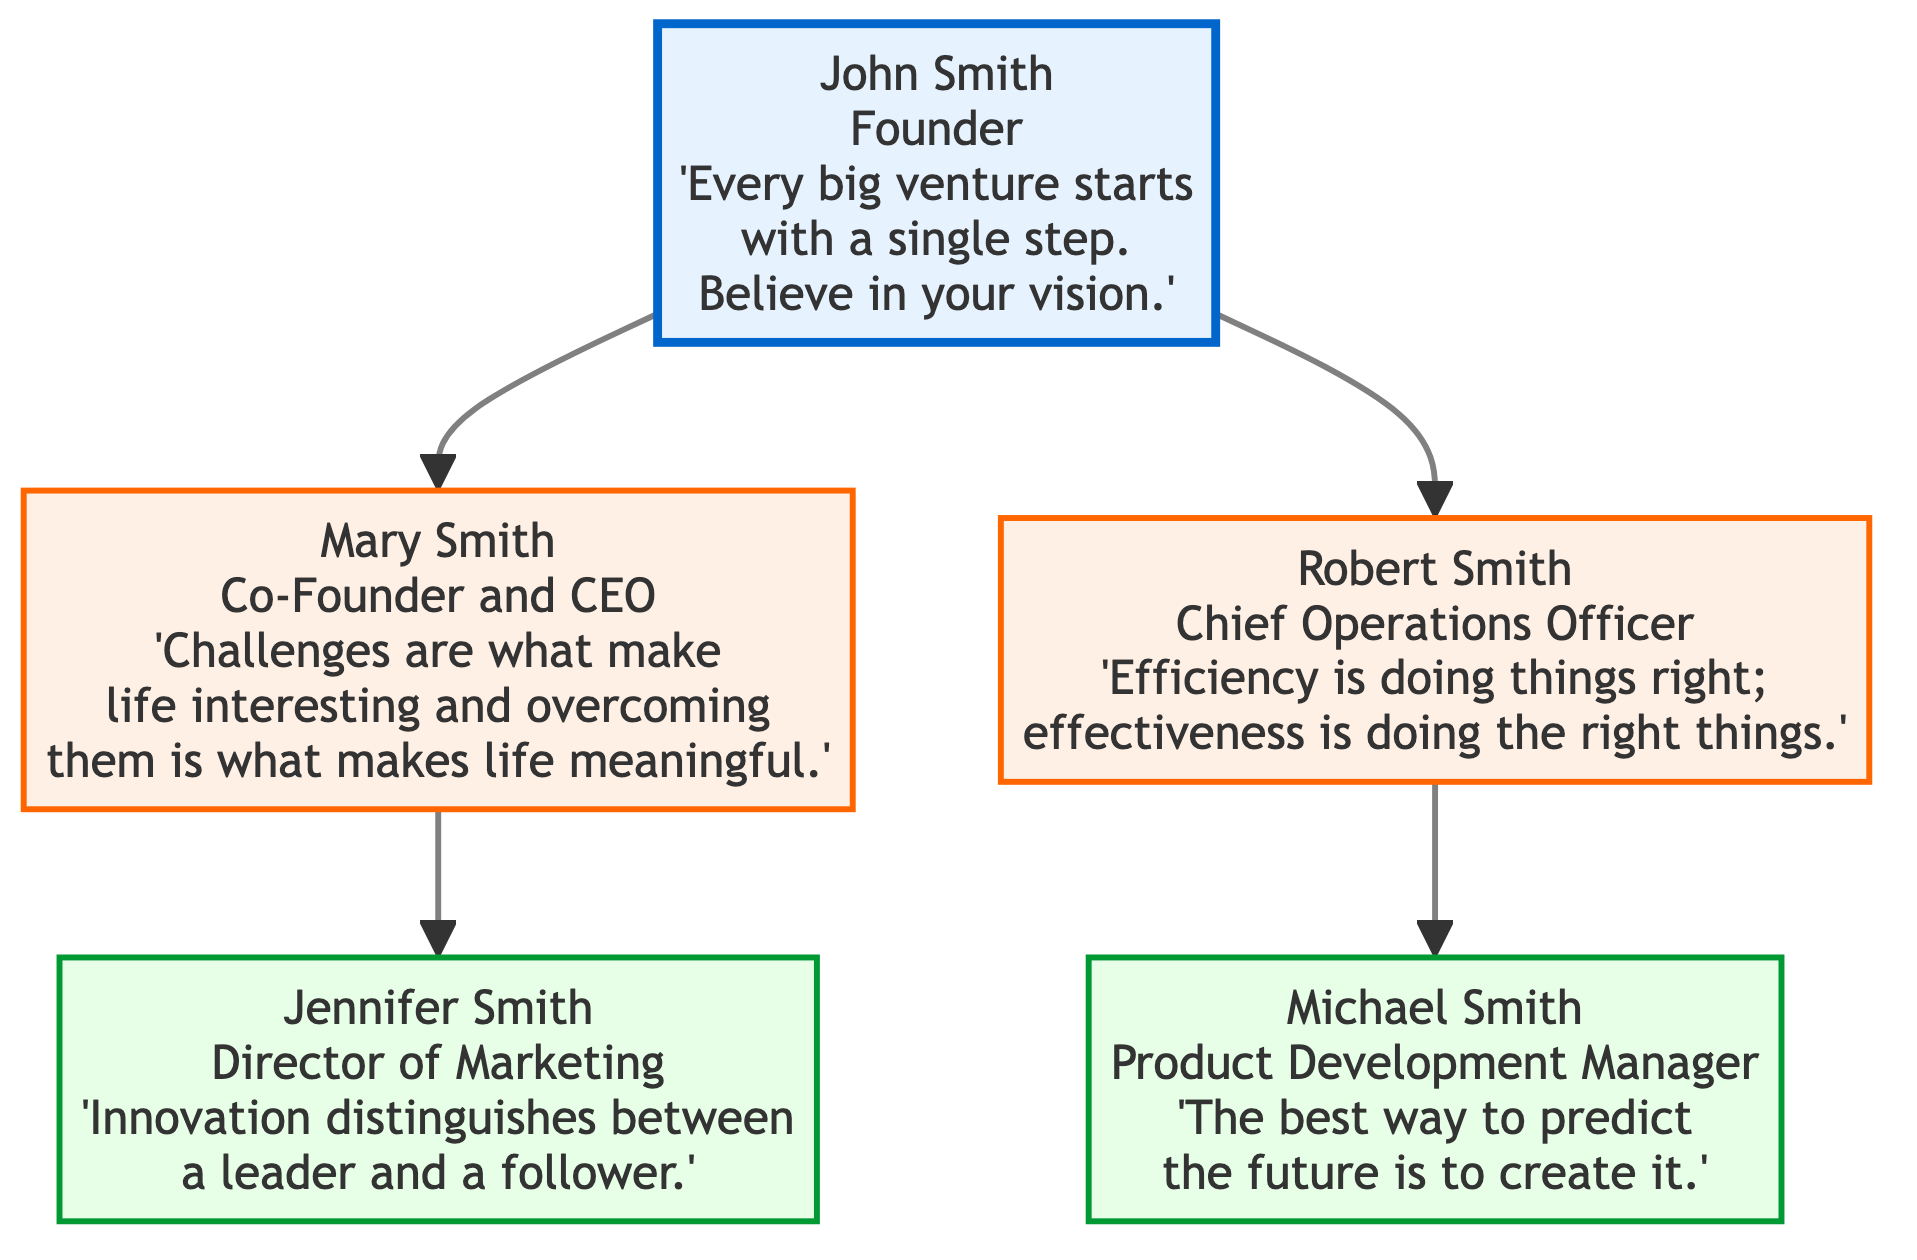What is the name of the founding member? The diagram identifies the founding member as John Smith. This is found at the top of the family tree, labeled clearly under the "founding_member" section.
Answer: John Smith How many members are there in the second generation? The second generation has two members listed: Mary Smith and Robert Smith. This is derived from the "second_generation" array which contains two entries.
Answer: 2 What role does Jennifer Smith hold? The diagram states that Jennifer Smith is the Director of Marketing. This information can be found in her individual box under the "third_generation" section.
Answer: Director of Marketing What quote is attributed to Robert Smith? Robert Smith's quote, "Efficiency is doing things right; effectiveness is doing the right things," is presented directly in the diagram next to his name and role.
Answer: Efficiency is doing things right; effectiveness is doing the right things Who is the Chief Operations Officer? In the diagram, Robert Smith is indicated as the Chief Operations Officer. This information is displayed prominently in his specific node.
Answer: Robert Smith How does Mary Smith relate to John Smith? Mary Smith is connected directly to John Smith as his Co-Founder and she is part of the second generation. The line connecting their nodes in the diagram denotes this direct relationship.
Answer: Daughter Which quote emphasizes innovation? The quote highlighting innovation, "Innovation distinguishes between a leader and a follower," is attributed to Jennifer Smith. It is found in her section of the third generation.
Answer: Innovation distinguishes between a leader and a follower How many generations are represented in the diagram? The diagram showcases three generations: founding member, second generation, and third generation, totaling to three distinct layers.
Answer: 3 What role does Michael Smith play in the family business? Michael Smith is designated as the Product Development Manager according to his node in the third generation section.
Answer: Product Development Manager 